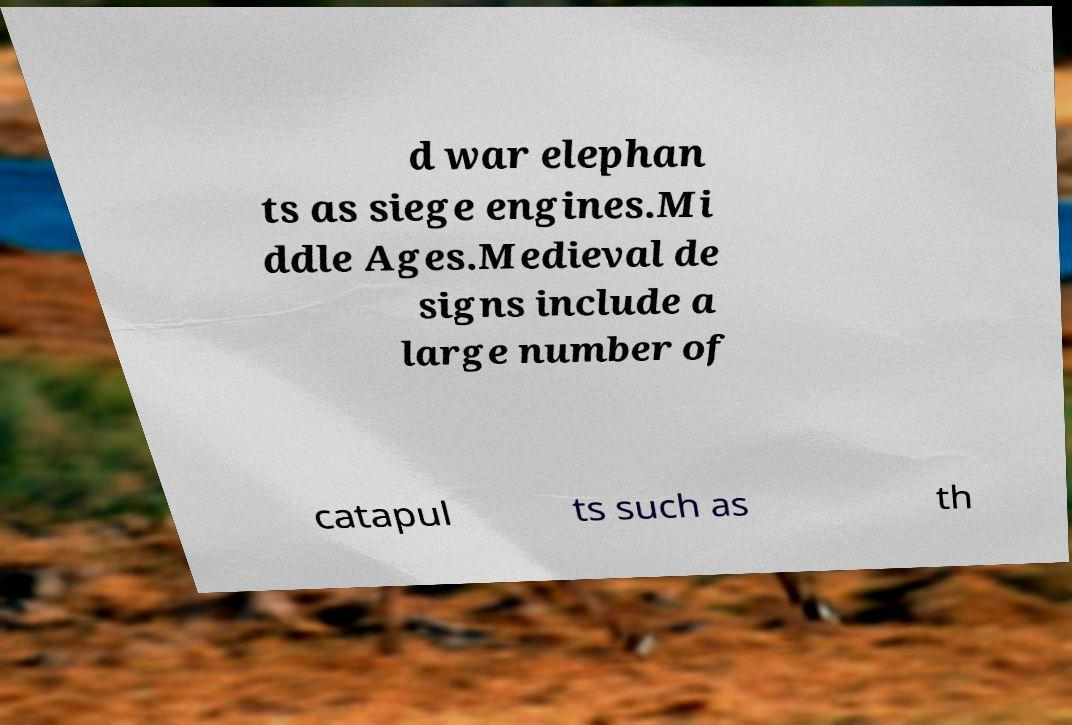Please identify and transcribe the text found in this image. d war elephan ts as siege engines.Mi ddle Ages.Medieval de signs include a large number of catapul ts such as th 